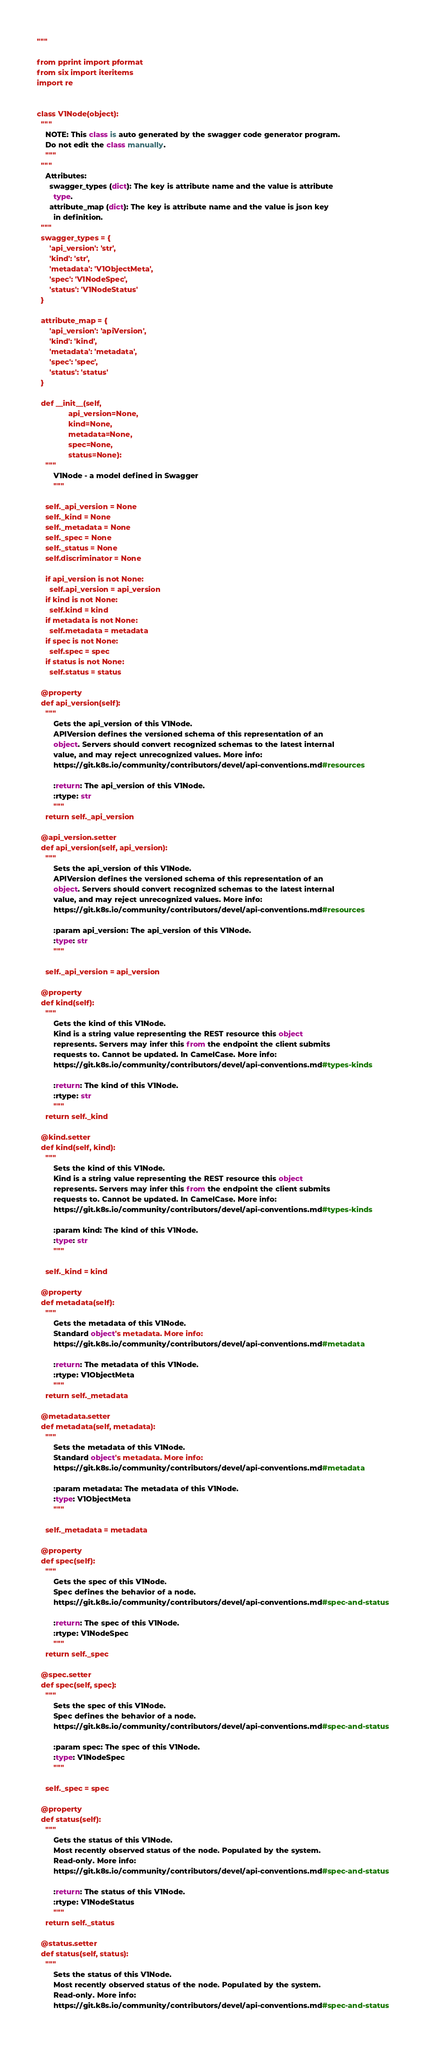Convert code to text. <code><loc_0><loc_0><loc_500><loc_500><_Python_>"""

from pprint import pformat
from six import iteritems
import re


class V1Node(object):
  """
    NOTE: This class is auto generated by the swagger code generator program.
    Do not edit the class manually.
    """
  """
    Attributes:
      swagger_types (dict): The key is attribute name and the value is attribute
        type.
      attribute_map (dict): The key is attribute name and the value is json key
        in definition.
  """
  swagger_types = {
      'api_version': 'str',
      'kind': 'str',
      'metadata': 'V1ObjectMeta',
      'spec': 'V1NodeSpec',
      'status': 'V1NodeStatus'
  }

  attribute_map = {
      'api_version': 'apiVersion',
      'kind': 'kind',
      'metadata': 'metadata',
      'spec': 'spec',
      'status': 'status'
  }

  def __init__(self,
               api_version=None,
               kind=None,
               metadata=None,
               spec=None,
               status=None):
    """
        V1Node - a model defined in Swagger
        """

    self._api_version = None
    self._kind = None
    self._metadata = None
    self._spec = None
    self._status = None
    self.discriminator = None

    if api_version is not None:
      self.api_version = api_version
    if kind is not None:
      self.kind = kind
    if metadata is not None:
      self.metadata = metadata
    if spec is not None:
      self.spec = spec
    if status is not None:
      self.status = status

  @property
  def api_version(self):
    """
        Gets the api_version of this V1Node.
        APIVersion defines the versioned schema of this representation of an
        object. Servers should convert recognized schemas to the latest internal
        value, and may reject unrecognized values. More info:
        https://git.k8s.io/community/contributors/devel/api-conventions.md#resources

        :return: The api_version of this V1Node.
        :rtype: str
        """
    return self._api_version

  @api_version.setter
  def api_version(self, api_version):
    """
        Sets the api_version of this V1Node.
        APIVersion defines the versioned schema of this representation of an
        object. Servers should convert recognized schemas to the latest internal
        value, and may reject unrecognized values. More info:
        https://git.k8s.io/community/contributors/devel/api-conventions.md#resources

        :param api_version: The api_version of this V1Node.
        :type: str
        """

    self._api_version = api_version

  @property
  def kind(self):
    """
        Gets the kind of this V1Node.
        Kind is a string value representing the REST resource this object
        represents. Servers may infer this from the endpoint the client submits
        requests to. Cannot be updated. In CamelCase. More info:
        https://git.k8s.io/community/contributors/devel/api-conventions.md#types-kinds

        :return: The kind of this V1Node.
        :rtype: str
        """
    return self._kind

  @kind.setter
  def kind(self, kind):
    """
        Sets the kind of this V1Node.
        Kind is a string value representing the REST resource this object
        represents. Servers may infer this from the endpoint the client submits
        requests to. Cannot be updated. In CamelCase. More info:
        https://git.k8s.io/community/contributors/devel/api-conventions.md#types-kinds

        :param kind: The kind of this V1Node.
        :type: str
        """

    self._kind = kind

  @property
  def metadata(self):
    """
        Gets the metadata of this V1Node.
        Standard object's metadata. More info:
        https://git.k8s.io/community/contributors/devel/api-conventions.md#metadata

        :return: The metadata of this V1Node.
        :rtype: V1ObjectMeta
        """
    return self._metadata

  @metadata.setter
  def metadata(self, metadata):
    """
        Sets the metadata of this V1Node.
        Standard object's metadata. More info:
        https://git.k8s.io/community/contributors/devel/api-conventions.md#metadata

        :param metadata: The metadata of this V1Node.
        :type: V1ObjectMeta
        """

    self._metadata = metadata

  @property
  def spec(self):
    """
        Gets the spec of this V1Node.
        Spec defines the behavior of a node.
        https://git.k8s.io/community/contributors/devel/api-conventions.md#spec-and-status

        :return: The spec of this V1Node.
        :rtype: V1NodeSpec
        """
    return self._spec

  @spec.setter
  def spec(self, spec):
    """
        Sets the spec of this V1Node.
        Spec defines the behavior of a node.
        https://git.k8s.io/community/contributors/devel/api-conventions.md#spec-and-status

        :param spec: The spec of this V1Node.
        :type: V1NodeSpec
        """

    self._spec = spec

  @property
  def status(self):
    """
        Gets the status of this V1Node.
        Most recently observed status of the node. Populated by the system.
        Read-only. More info:
        https://git.k8s.io/community/contributors/devel/api-conventions.md#spec-and-status

        :return: The status of this V1Node.
        :rtype: V1NodeStatus
        """
    return self._status

  @status.setter
  def status(self, status):
    """
        Sets the status of this V1Node.
        Most recently observed status of the node. Populated by the system.
        Read-only. More info:
        https://git.k8s.io/community/contributors/devel/api-conventions.md#spec-and-status
</code> 